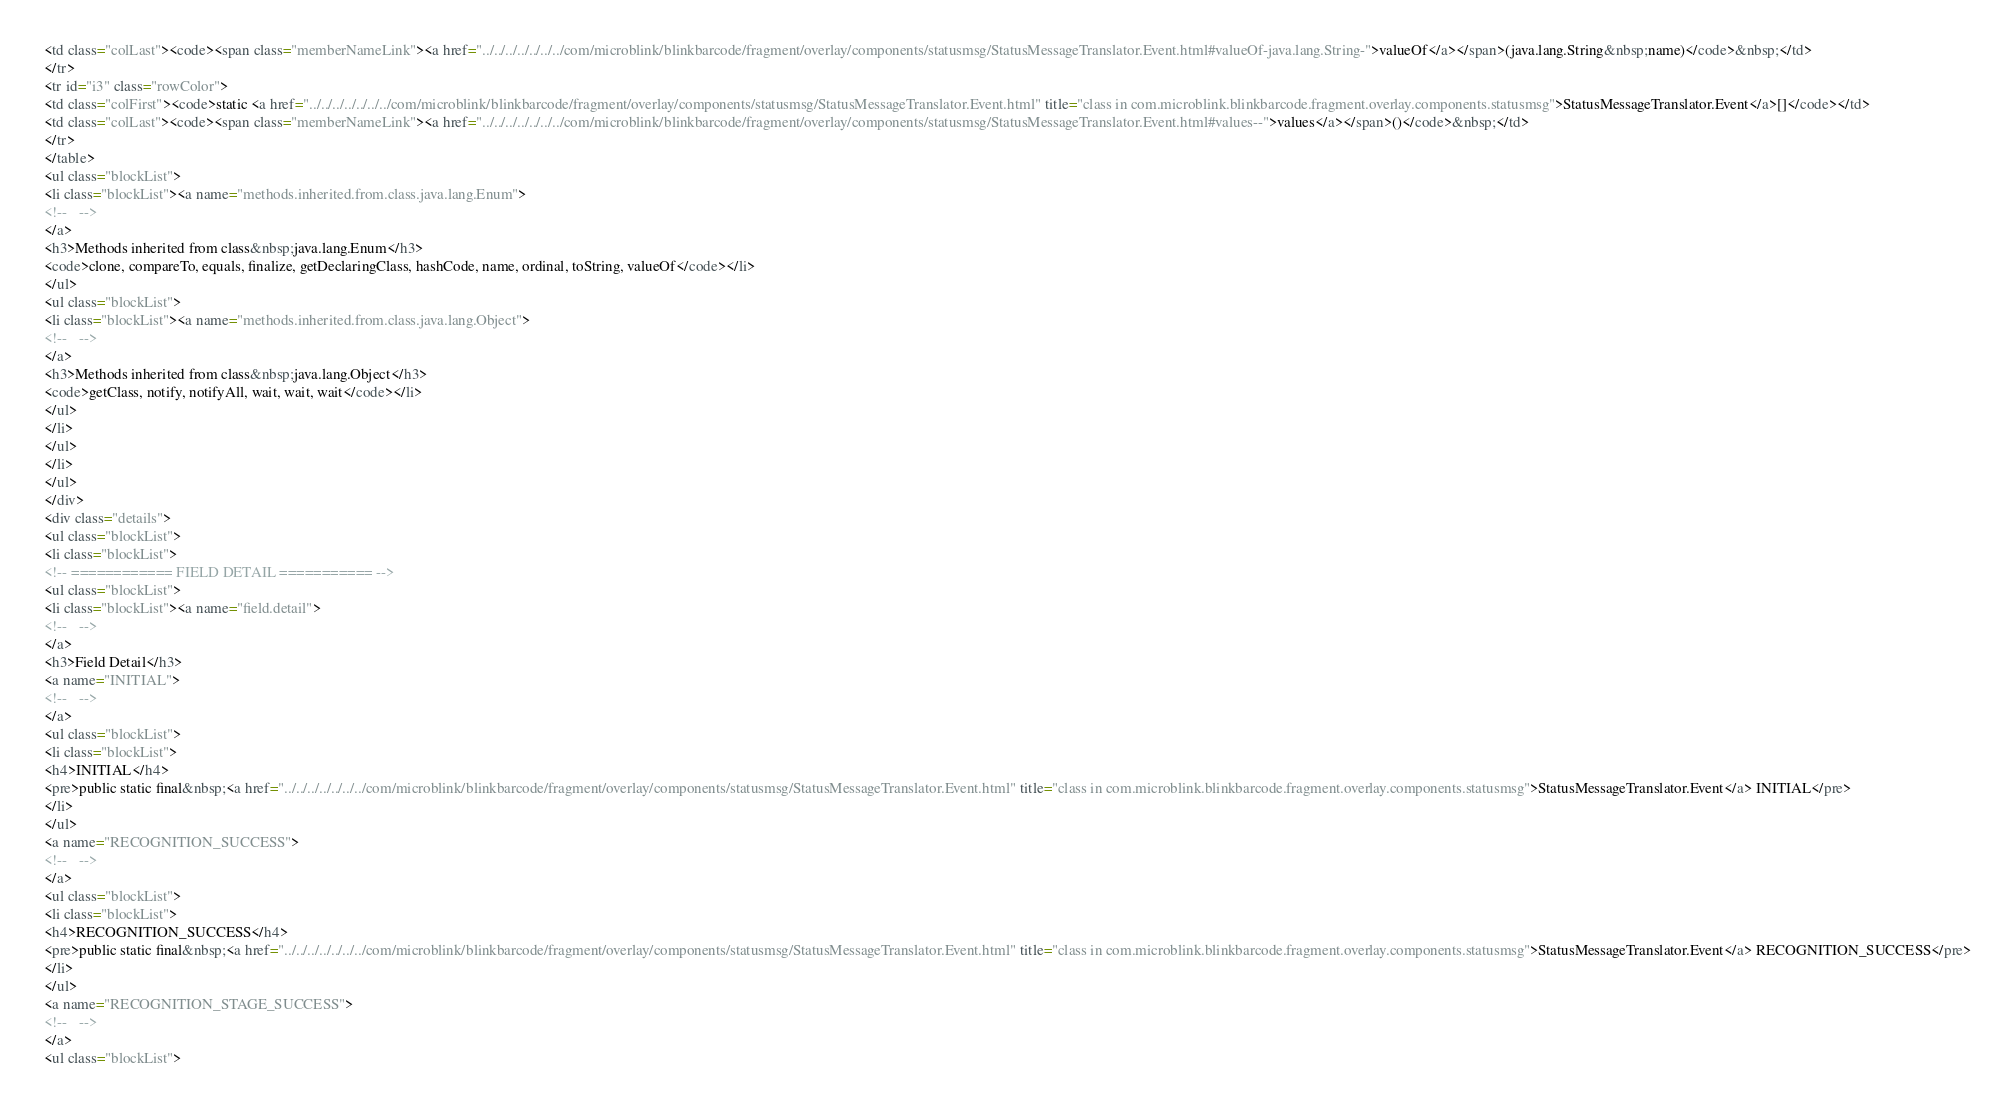Convert code to text. <code><loc_0><loc_0><loc_500><loc_500><_HTML_><td class="colLast"><code><span class="memberNameLink"><a href="../../../../../../../com/microblink/blinkbarcode/fragment/overlay/components/statusmsg/StatusMessageTranslator.Event.html#valueOf-java.lang.String-">valueOf</a></span>(java.lang.String&nbsp;name)</code>&nbsp;</td>
</tr>
<tr id="i3" class="rowColor">
<td class="colFirst"><code>static <a href="../../../../../../../com/microblink/blinkbarcode/fragment/overlay/components/statusmsg/StatusMessageTranslator.Event.html" title="class in com.microblink.blinkbarcode.fragment.overlay.components.statusmsg">StatusMessageTranslator.Event</a>[]</code></td>
<td class="colLast"><code><span class="memberNameLink"><a href="../../../../../../../com/microblink/blinkbarcode/fragment/overlay/components/statusmsg/StatusMessageTranslator.Event.html#values--">values</a></span>()</code>&nbsp;</td>
</tr>
</table>
<ul class="blockList">
<li class="blockList"><a name="methods.inherited.from.class.java.lang.Enum">
<!--   -->
</a>
<h3>Methods inherited from class&nbsp;java.lang.Enum</h3>
<code>clone, compareTo, equals, finalize, getDeclaringClass, hashCode, name, ordinal, toString, valueOf</code></li>
</ul>
<ul class="blockList">
<li class="blockList"><a name="methods.inherited.from.class.java.lang.Object">
<!--   -->
</a>
<h3>Methods inherited from class&nbsp;java.lang.Object</h3>
<code>getClass, notify, notifyAll, wait, wait, wait</code></li>
</ul>
</li>
</ul>
</li>
</ul>
</div>
<div class="details">
<ul class="blockList">
<li class="blockList">
<!-- ============ FIELD DETAIL =========== -->
<ul class="blockList">
<li class="blockList"><a name="field.detail">
<!--   -->
</a>
<h3>Field Detail</h3>
<a name="INITIAL">
<!--   -->
</a>
<ul class="blockList">
<li class="blockList">
<h4>INITIAL</h4>
<pre>public static final&nbsp;<a href="../../../../../../../com/microblink/blinkbarcode/fragment/overlay/components/statusmsg/StatusMessageTranslator.Event.html" title="class in com.microblink.blinkbarcode.fragment.overlay.components.statusmsg">StatusMessageTranslator.Event</a> INITIAL</pre>
</li>
</ul>
<a name="RECOGNITION_SUCCESS">
<!--   -->
</a>
<ul class="blockList">
<li class="blockList">
<h4>RECOGNITION_SUCCESS</h4>
<pre>public static final&nbsp;<a href="../../../../../../../com/microblink/blinkbarcode/fragment/overlay/components/statusmsg/StatusMessageTranslator.Event.html" title="class in com.microblink.blinkbarcode.fragment.overlay.components.statusmsg">StatusMessageTranslator.Event</a> RECOGNITION_SUCCESS</pre>
</li>
</ul>
<a name="RECOGNITION_STAGE_SUCCESS">
<!--   -->
</a>
<ul class="blockList"></code> 